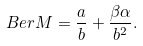<formula> <loc_0><loc_0><loc_500><loc_500>B e r M = \frac { a } { b } + \frac { \beta \alpha } { b ^ { 2 } } .</formula> 